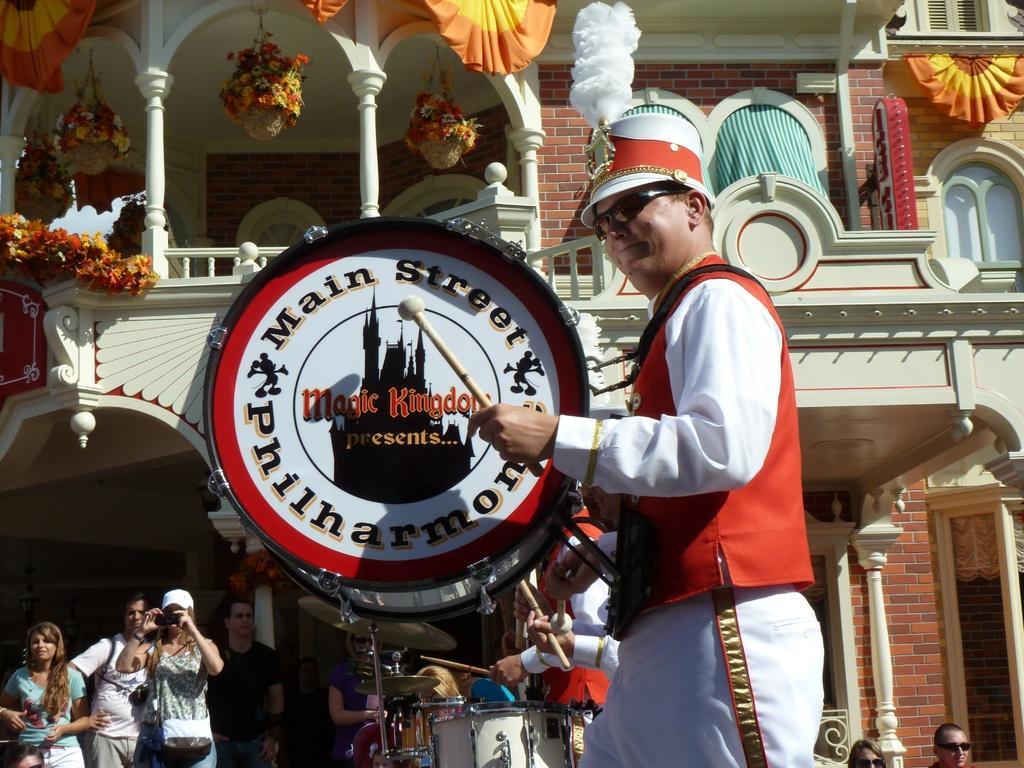Describe this image in one or two sentences. In this image I can see there are few persons holding musical instruments , at the bottom I can see few persons there is a building visible , on the roof of building there is a flower pots hanging and there is a design cloth visible on the wall of the building. 